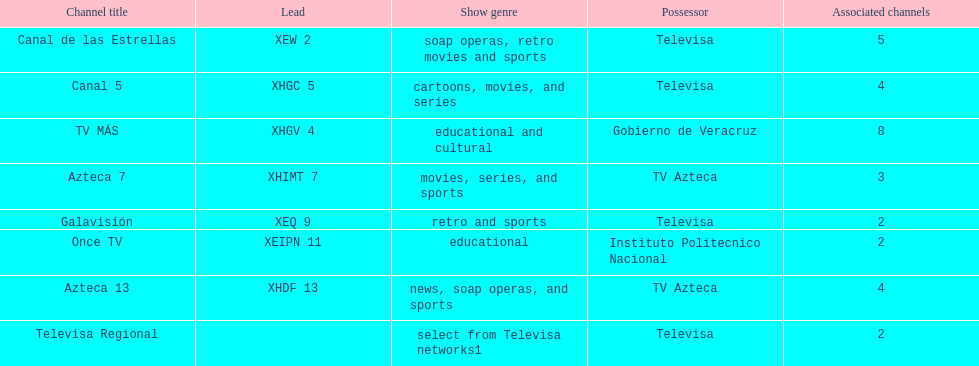What is the number of affiliates of canal de las estrellas. 5. 